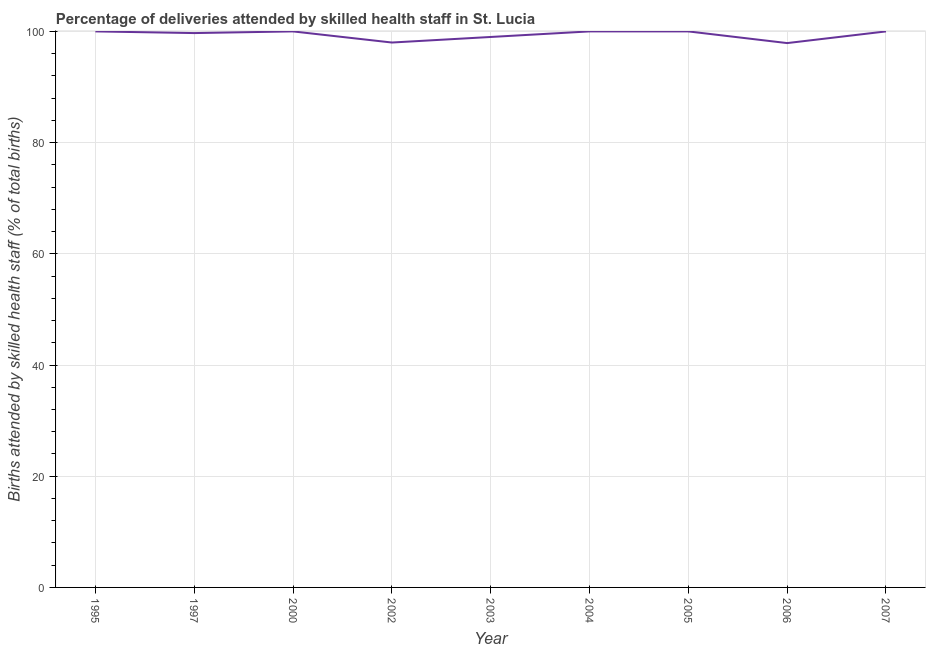Across all years, what is the maximum number of births attended by skilled health staff?
Make the answer very short. 100. Across all years, what is the minimum number of births attended by skilled health staff?
Your response must be concise. 97.9. In which year was the number of births attended by skilled health staff minimum?
Keep it short and to the point. 2006. What is the sum of the number of births attended by skilled health staff?
Your response must be concise. 894.6. What is the difference between the number of births attended by skilled health staff in 1995 and 2000?
Keep it short and to the point. 0. What is the average number of births attended by skilled health staff per year?
Your response must be concise. 99.4. In how many years, is the number of births attended by skilled health staff greater than 76 %?
Give a very brief answer. 9. What is the ratio of the number of births attended by skilled health staff in 1995 to that in 1997?
Your response must be concise. 1. Is the difference between the number of births attended by skilled health staff in 2003 and 2004 greater than the difference between any two years?
Provide a succinct answer. No. What is the difference between the highest and the lowest number of births attended by skilled health staff?
Offer a very short reply. 2.1. Does the number of births attended by skilled health staff monotonically increase over the years?
Provide a short and direct response. No. How many lines are there?
Provide a succinct answer. 1. What is the difference between two consecutive major ticks on the Y-axis?
Keep it short and to the point. 20. Does the graph contain grids?
Provide a short and direct response. Yes. What is the title of the graph?
Make the answer very short. Percentage of deliveries attended by skilled health staff in St. Lucia. What is the label or title of the Y-axis?
Offer a very short reply. Births attended by skilled health staff (% of total births). What is the Births attended by skilled health staff (% of total births) of 1997?
Offer a very short reply. 99.7. What is the Births attended by skilled health staff (% of total births) in 2005?
Give a very brief answer. 100. What is the Births attended by skilled health staff (% of total births) in 2006?
Keep it short and to the point. 97.9. What is the difference between the Births attended by skilled health staff (% of total births) in 1995 and 1997?
Offer a very short reply. 0.3. What is the difference between the Births attended by skilled health staff (% of total births) in 1995 and 2002?
Make the answer very short. 2. What is the difference between the Births attended by skilled health staff (% of total births) in 1995 and 2004?
Keep it short and to the point. 0. What is the difference between the Births attended by skilled health staff (% of total births) in 1995 and 2005?
Provide a short and direct response. 0. What is the difference between the Births attended by skilled health staff (% of total births) in 1995 and 2007?
Offer a very short reply. 0. What is the difference between the Births attended by skilled health staff (% of total births) in 1997 and 2002?
Offer a very short reply. 1.7. What is the difference between the Births attended by skilled health staff (% of total births) in 1997 and 2004?
Provide a succinct answer. -0.3. What is the difference between the Births attended by skilled health staff (% of total births) in 1997 and 2005?
Provide a succinct answer. -0.3. What is the difference between the Births attended by skilled health staff (% of total births) in 1997 and 2006?
Your answer should be very brief. 1.8. What is the difference between the Births attended by skilled health staff (% of total births) in 1997 and 2007?
Make the answer very short. -0.3. What is the difference between the Births attended by skilled health staff (% of total births) in 2000 and 2003?
Give a very brief answer. 1. What is the difference between the Births attended by skilled health staff (% of total births) in 2000 and 2004?
Offer a very short reply. 0. What is the difference between the Births attended by skilled health staff (% of total births) in 2000 and 2005?
Offer a terse response. 0. What is the difference between the Births attended by skilled health staff (% of total births) in 2000 and 2007?
Offer a very short reply. 0. What is the difference between the Births attended by skilled health staff (% of total births) in 2002 and 2003?
Offer a very short reply. -1. What is the difference between the Births attended by skilled health staff (% of total births) in 2002 and 2005?
Provide a succinct answer. -2. What is the difference between the Births attended by skilled health staff (% of total births) in 2002 and 2007?
Provide a succinct answer. -2. What is the difference between the Births attended by skilled health staff (% of total births) in 2003 and 2007?
Keep it short and to the point. -1. What is the difference between the Births attended by skilled health staff (% of total births) in 2004 and 2007?
Offer a terse response. 0. What is the ratio of the Births attended by skilled health staff (% of total births) in 1995 to that in 2000?
Provide a succinct answer. 1. What is the ratio of the Births attended by skilled health staff (% of total births) in 1995 to that in 2003?
Provide a short and direct response. 1.01. What is the ratio of the Births attended by skilled health staff (% of total births) in 1995 to that in 2005?
Provide a short and direct response. 1. What is the ratio of the Births attended by skilled health staff (% of total births) in 1995 to that in 2006?
Your answer should be very brief. 1.02. What is the ratio of the Births attended by skilled health staff (% of total births) in 1995 to that in 2007?
Offer a very short reply. 1. What is the ratio of the Births attended by skilled health staff (% of total births) in 1997 to that in 2000?
Offer a terse response. 1. What is the ratio of the Births attended by skilled health staff (% of total births) in 1997 to that in 2003?
Offer a terse response. 1.01. What is the ratio of the Births attended by skilled health staff (% of total births) in 2000 to that in 2005?
Offer a very short reply. 1. What is the ratio of the Births attended by skilled health staff (% of total births) in 2000 to that in 2006?
Ensure brevity in your answer.  1.02. What is the ratio of the Births attended by skilled health staff (% of total births) in 2002 to that in 2004?
Offer a terse response. 0.98. What is the ratio of the Births attended by skilled health staff (% of total births) in 2002 to that in 2005?
Your answer should be compact. 0.98. What is the ratio of the Births attended by skilled health staff (% of total births) in 2003 to that in 2006?
Provide a short and direct response. 1.01. What is the ratio of the Births attended by skilled health staff (% of total births) in 2003 to that in 2007?
Provide a short and direct response. 0.99. What is the ratio of the Births attended by skilled health staff (% of total births) in 2004 to that in 2005?
Give a very brief answer. 1. What is the ratio of the Births attended by skilled health staff (% of total births) in 2004 to that in 2006?
Your answer should be compact. 1.02. 